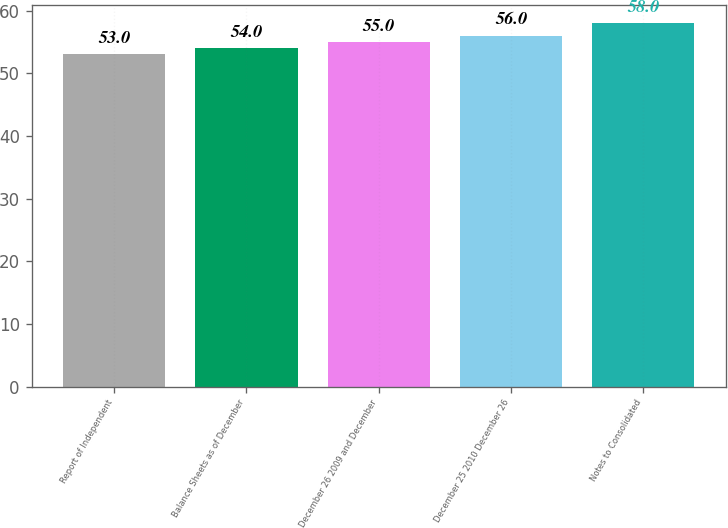Convert chart. <chart><loc_0><loc_0><loc_500><loc_500><bar_chart><fcel>Report of Independent<fcel>Balance Sheets as of December<fcel>December 26 2009 and December<fcel>December 25 2010 December 26<fcel>Notes to Consolidated<nl><fcel>53<fcel>54<fcel>55<fcel>56<fcel>58<nl></chart> 